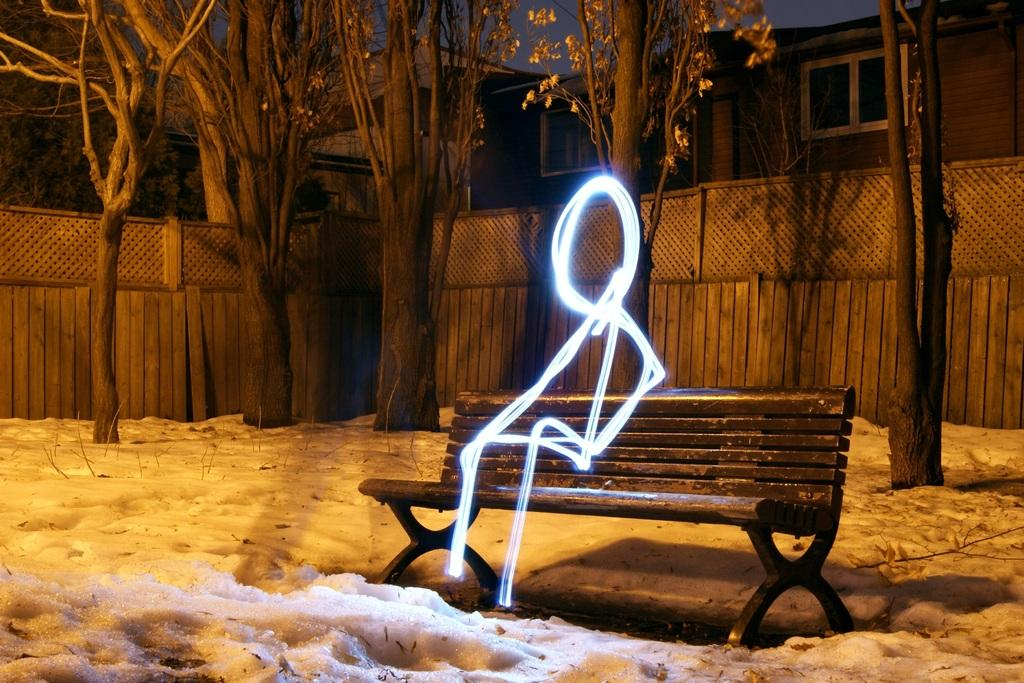What type of natural elements can be seen in the image? There are seeds and trees visible in the image. What is the ground condition in the image? There is snow at the bottom of the image. What type of structure is present in the image? There is a bench in the image. Can you describe the person depicted in the image? The image contains a depiction of a person. What is visible in the sky in the image? The sky is visible in the image. What type of barrier is present in the image? There is a fence in the image. How many vases are present in the image? There are no vases present in the image. Can you describe the behavior of the cats in the image? There are no cats present in the image. 